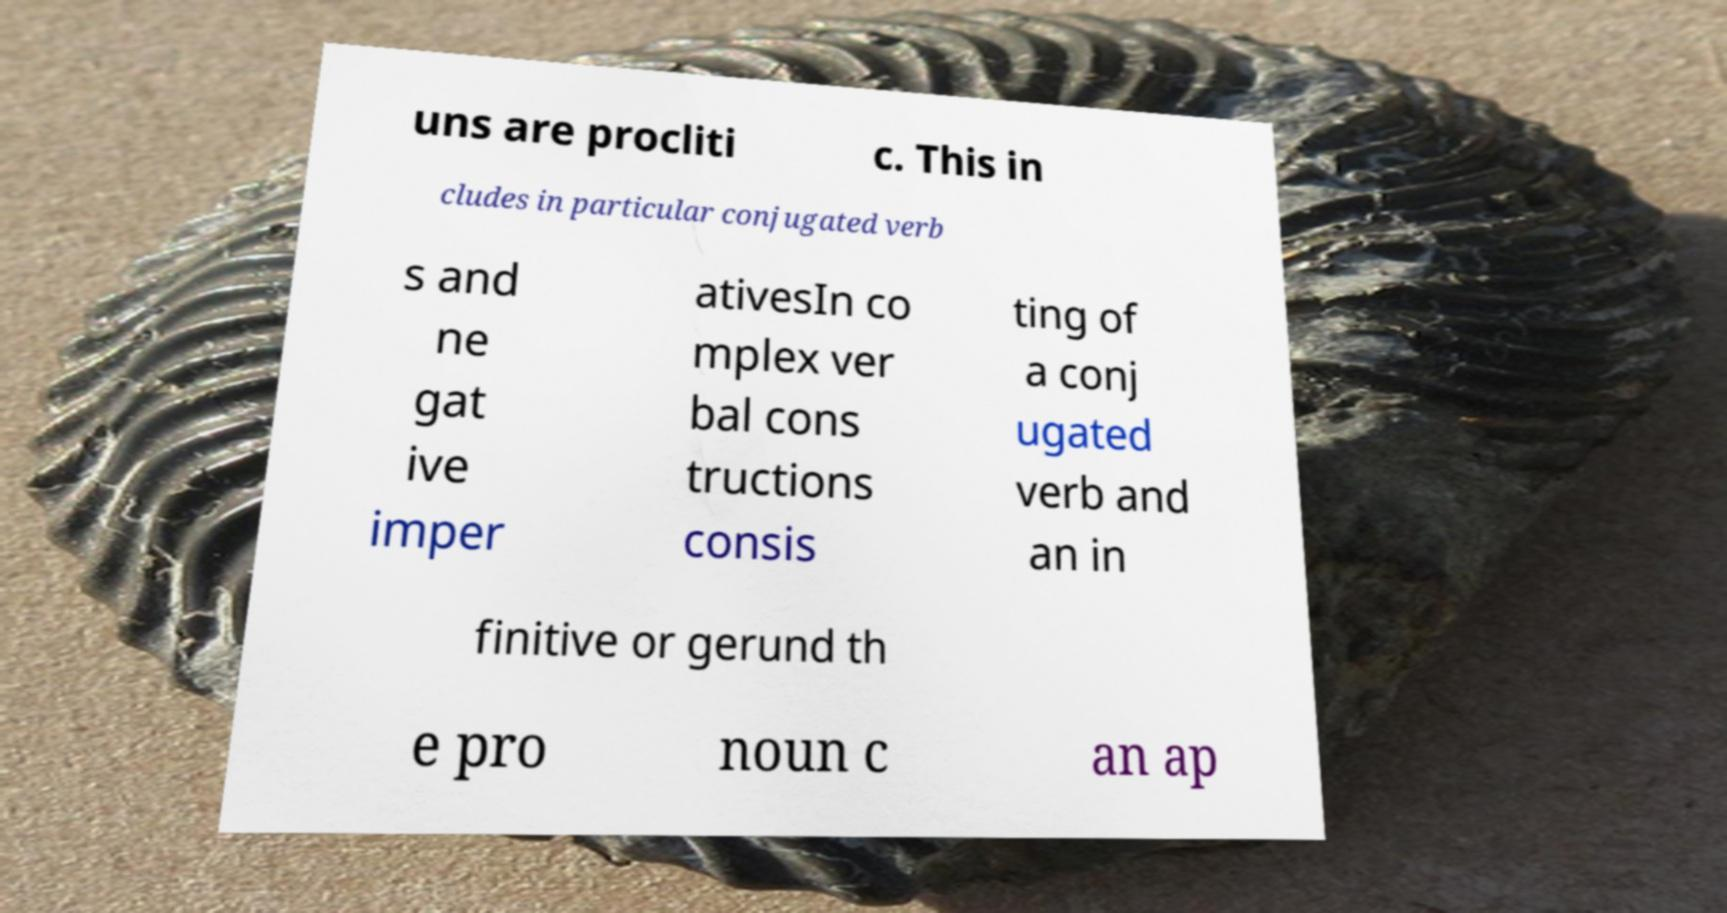Please read and relay the text visible in this image. What does it say? uns are procliti c. This in cludes in particular conjugated verb s and ne gat ive imper ativesIn co mplex ver bal cons tructions consis ting of a conj ugated verb and an in finitive or gerund th e pro noun c an ap 